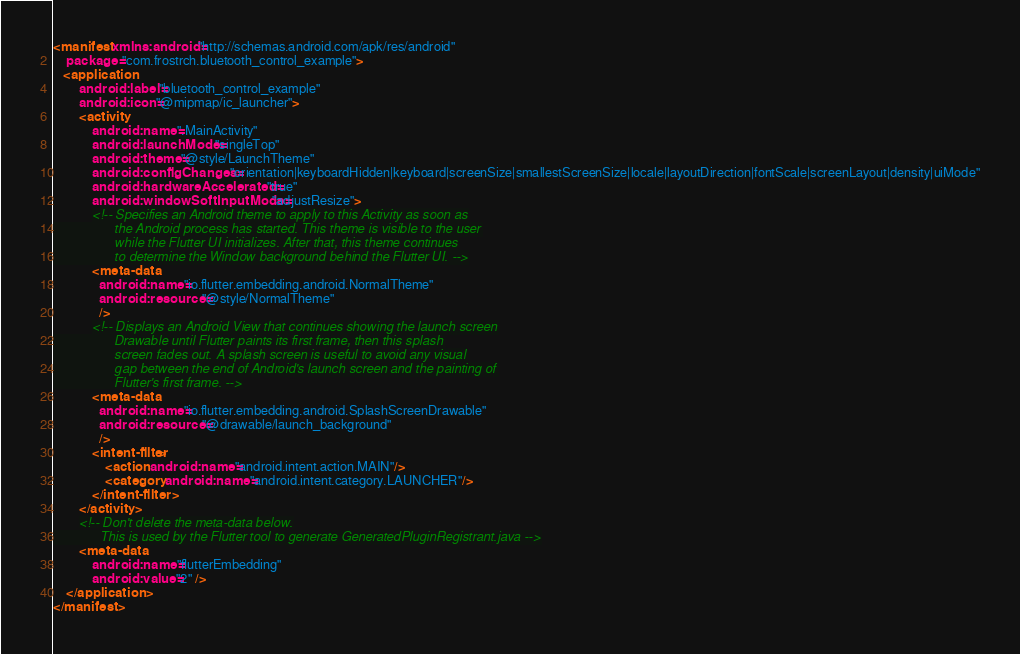Convert code to text. <code><loc_0><loc_0><loc_500><loc_500><_XML_><manifest xmlns:android="http://schemas.android.com/apk/res/android"
    package="com.frostrch.bluetooth_control_example">
   <application
        android:label="bluetooth_control_example"
        android:icon="@mipmap/ic_launcher">
        <activity
            android:name=".MainActivity"
            android:launchMode="singleTop"
            android:theme="@style/LaunchTheme"
            android:configChanges="orientation|keyboardHidden|keyboard|screenSize|smallestScreenSize|locale|layoutDirection|fontScale|screenLayout|density|uiMode"
            android:hardwareAccelerated="true"
            android:windowSoftInputMode="adjustResize">
            <!-- Specifies an Android theme to apply to this Activity as soon as
                 the Android process has started. This theme is visible to the user
                 while the Flutter UI initializes. After that, this theme continues
                 to determine the Window background behind the Flutter UI. -->
            <meta-data
              android:name="io.flutter.embedding.android.NormalTheme"
              android:resource="@style/NormalTheme"
              />
            <!-- Displays an Android View that continues showing the launch screen
                 Drawable until Flutter paints its first frame, then this splash
                 screen fades out. A splash screen is useful to avoid any visual
                 gap between the end of Android's launch screen and the painting of
                 Flutter's first frame. -->
            <meta-data
              android:name="io.flutter.embedding.android.SplashScreenDrawable"
              android:resource="@drawable/launch_background"
              />
            <intent-filter>
                <action android:name="android.intent.action.MAIN"/>
                <category android:name="android.intent.category.LAUNCHER"/>
            </intent-filter>
        </activity>
        <!-- Don't delete the meta-data below.
             This is used by the Flutter tool to generate GeneratedPluginRegistrant.java -->
        <meta-data
            android:name="flutterEmbedding"
            android:value="2" />
    </application>
</manifest>
</code> 